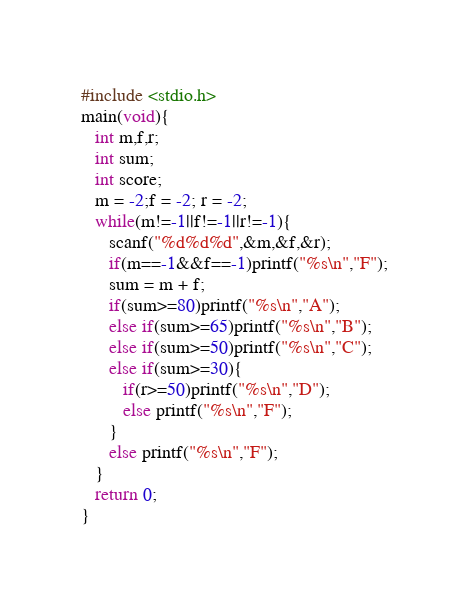<code> <loc_0><loc_0><loc_500><loc_500><_C_>#include <stdio.h>
main(void){
   int m,f,r;
   int sum;
   int score;
   m = -2;f = -2; r = -2;
   while(m!=-1||f!=-1||r!=-1){
      scanf("%d%d%d",&m,&f,&r);
      if(m==-1&&f==-1)printf("%s\n","F");
      sum = m + f;
      if(sum>=80)printf("%s\n","A");
      else if(sum>=65)printf("%s\n","B");
      else if(sum>=50)printf("%s\n","C");
      else if(sum>=30){
         if(r>=50)printf("%s\n","D");
         else printf("%s\n","F");
      }
      else printf("%s\n","F");
   }
   return 0;
}</code> 